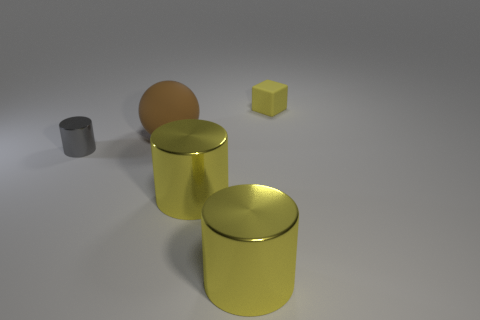There is a object that is made of the same material as the tiny cube; what is its size?
Your answer should be compact. Large. Do the metal cylinder on the left side of the brown sphere and the tiny block have the same size?
Offer a very short reply. Yes. How many cylinders are brown things or big yellow objects?
Keep it short and to the point. 2. There is a small thing right of the big rubber object; what is its material?
Offer a very short reply. Rubber. Are there fewer tiny blue matte cylinders than gray metallic cylinders?
Give a very brief answer. Yes. There is a object that is both on the right side of the big brown sphere and behind the gray cylinder; what size is it?
Your answer should be very brief. Small. What is the size of the yellow object behind the tiny thing that is on the left side of the tiny thing that is behind the gray metal object?
Provide a short and direct response. Small. How many other things are the same color as the small block?
Your answer should be compact. 2. What number of things are either large rubber spheres or large blue objects?
Your answer should be very brief. 1. What color is the small cylinder to the left of the brown rubber sphere?
Offer a very short reply. Gray. 